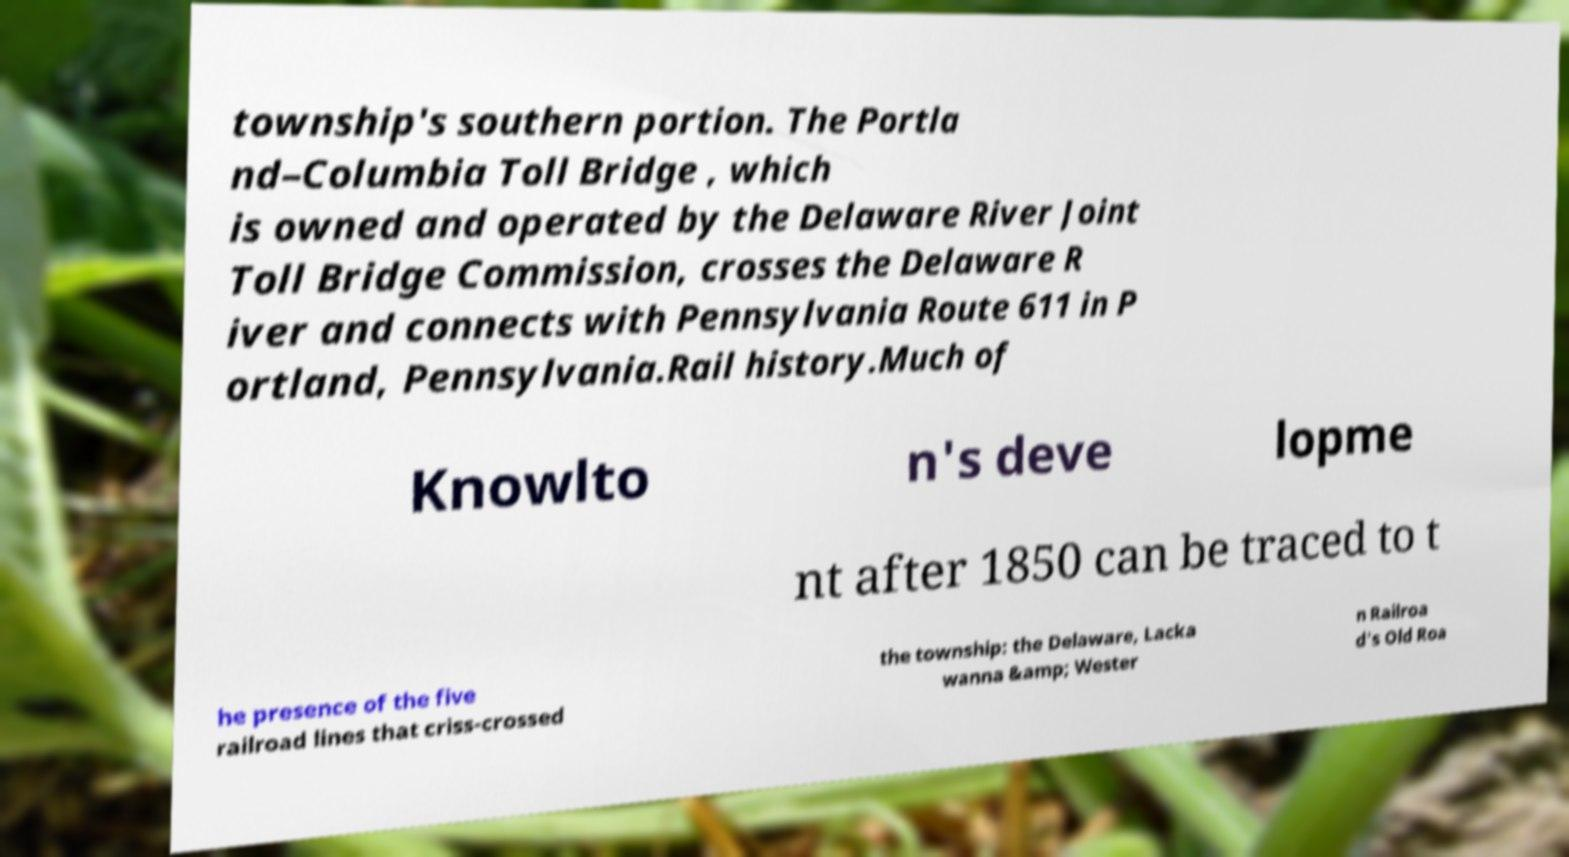Please read and relay the text visible in this image. What does it say? township's southern portion. The Portla nd–Columbia Toll Bridge , which is owned and operated by the Delaware River Joint Toll Bridge Commission, crosses the Delaware R iver and connects with Pennsylvania Route 611 in P ortland, Pennsylvania.Rail history.Much of Knowlto n's deve lopme nt after 1850 can be traced to t he presence of the five railroad lines that criss-crossed the township: the Delaware, Lacka wanna &amp; Wester n Railroa d's Old Roa 